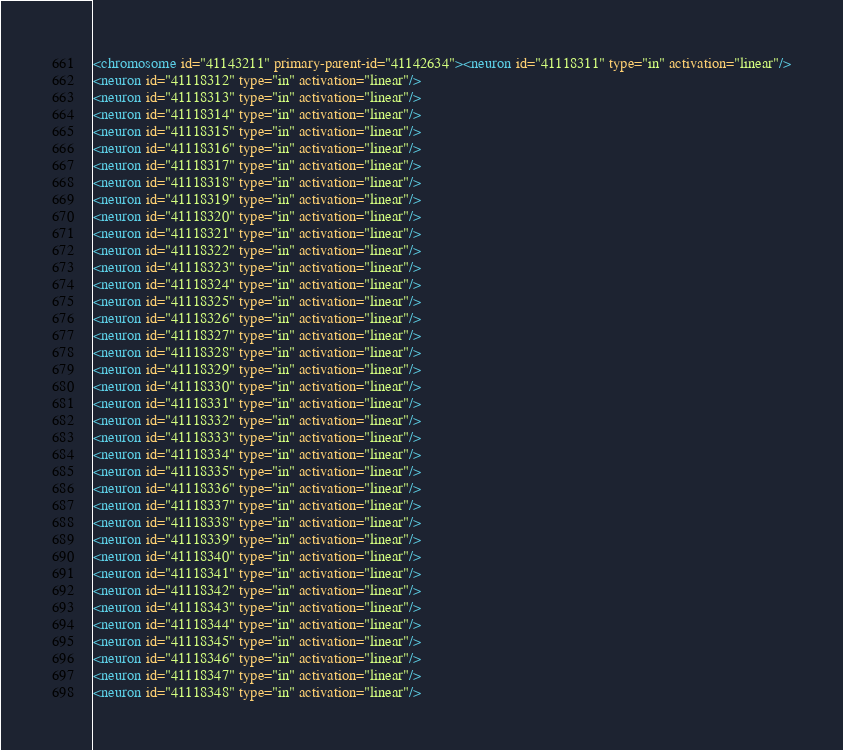Convert code to text. <code><loc_0><loc_0><loc_500><loc_500><_XML_><chromosome id="41143211" primary-parent-id="41142634"><neuron id="41118311" type="in" activation="linear"/>
<neuron id="41118312" type="in" activation="linear"/>
<neuron id="41118313" type="in" activation="linear"/>
<neuron id="41118314" type="in" activation="linear"/>
<neuron id="41118315" type="in" activation="linear"/>
<neuron id="41118316" type="in" activation="linear"/>
<neuron id="41118317" type="in" activation="linear"/>
<neuron id="41118318" type="in" activation="linear"/>
<neuron id="41118319" type="in" activation="linear"/>
<neuron id="41118320" type="in" activation="linear"/>
<neuron id="41118321" type="in" activation="linear"/>
<neuron id="41118322" type="in" activation="linear"/>
<neuron id="41118323" type="in" activation="linear"/>
<neuron id="41118324" type="in" activation="linear"/>
<neuron id="41118325" type="in" activation="linear"/>
<neuron id="41118326" type="in" activation="linear"/>
<neuron id="41118327" type="in" activation="linear"/>
<neuron id="41118328" type="in" activation="linear"/>
<neuron id="41118329" type="in" activation="linear"/>
<neuron id="41118330" type="in" activation="linear"/>
<neuron id="41118331" type="in" activation="linear"/>
<neuron id="41118332" type="in" activation="linear"/>
<neuron id="41118333" type="in" activation="linear"/>
<neuron id="41118334" type="in" activation="linear"/>
<neuron id="41118335" type="in" activation="linear"/>
<neuron id="41118336" type="in" activation="linear"/>
<neuron id="41118337" type="in" activation="linear"/>
<neuron id="41118338" type="in" activation="linear"/>
<neuron id="41118339" type="in" activation="linear"/>
<neuron id="41118340" type="in" activation="linear"/>
<neuron id="41118341" type="in" activation="linear"/>
<neuron id="41118342" type="in" activation="linear"/>
<neuron id="41118343" type="in" activation="linear"/>
<neuron id="41118344" type="in" activation="linear"/>
<neuron id="41118345" type="in" activation="linear"/>
<neuron id="41118346" type="in" activation="linear"/>
<neuron id="41118347" type="in" activation="linear"/>
<neuron id="41118348" type="in" activation="linear"/></code> 